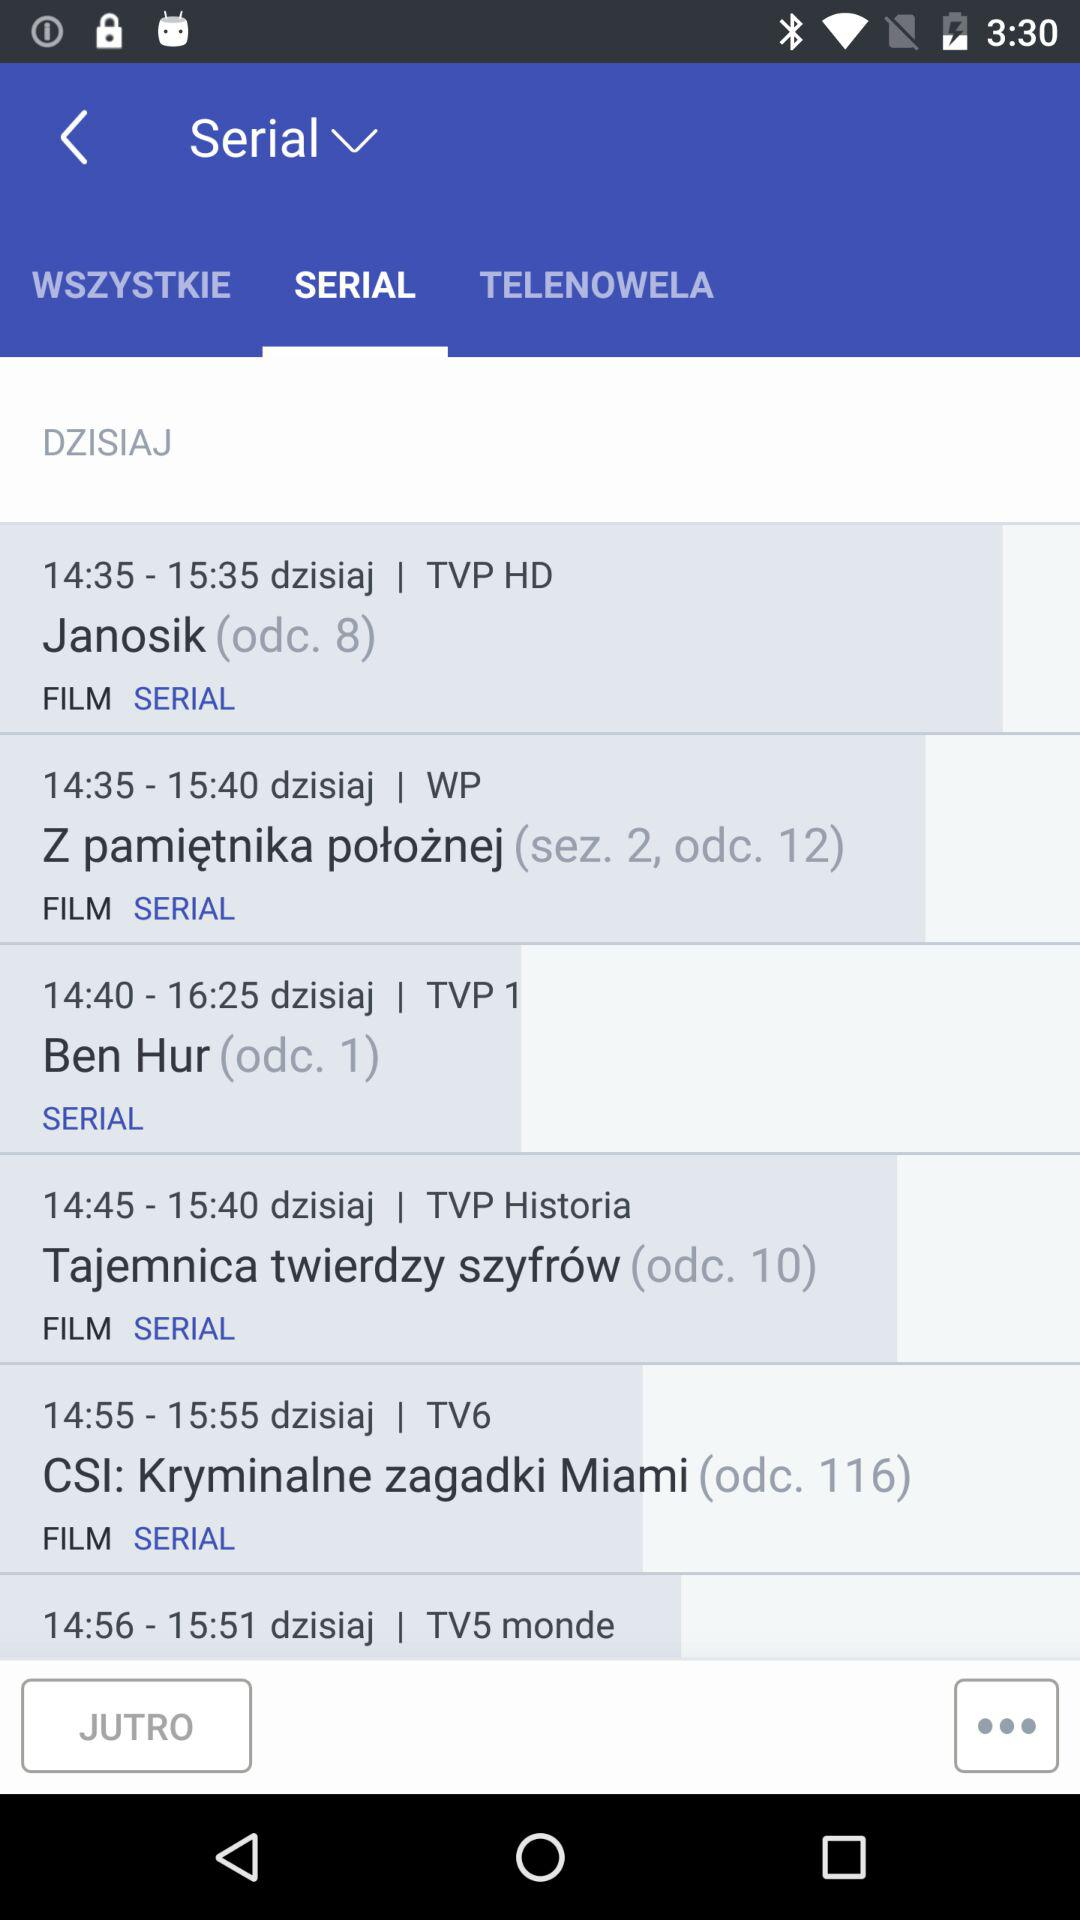What is the timing of the "Ben Hur" serial? The timing of the "Ben Hur" serial is from 14:40 to 16:25. 